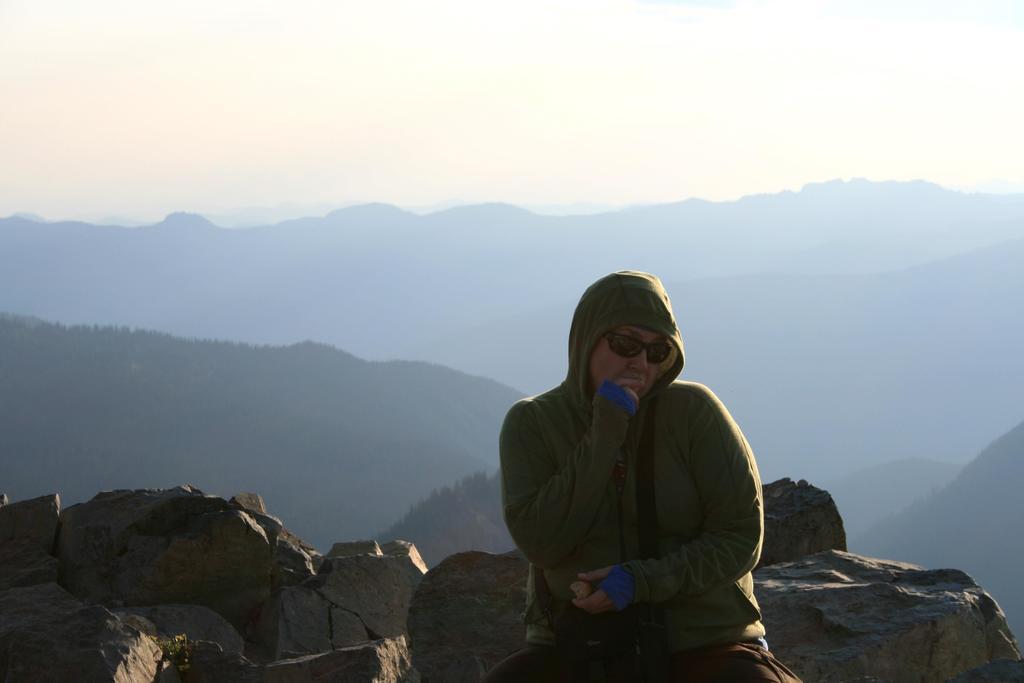In one or two sentences, can you explain what this image depicts? A person is sitting wearing a green hoodie and goggles. There are trees and mountains at the back. There is sky at the top. 